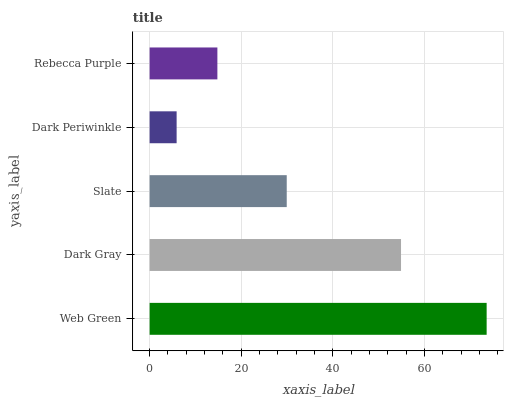Is Dark Periwinkle the minimum?
Answer yes or no. Yes. Is Web Green the maximum?
Answer yes or no. Yes. Is Dark Gray the minimum?
Answer yes or no. No. Is Dark Gray the maximum?
Answer yes or no. No. Is Web Green greater than Dark Gray?
Answer yes or no. Yes. Is Dark Gray less than Web Green?
Answer yes or no. Yes. Is Dark Gray greater than Web Green?
Answer yes or no. No. Is Web Green less than Dark Gray?
Answer yes or no. No. Is Slate the high median?
Answer yes or no. Yes. Is Slate the low median?
Answer yes or no. Yes. Is Dark Gray the high median?
Answer yes or no. No. Is Web Green the low median?
Answer yes or no. No. 